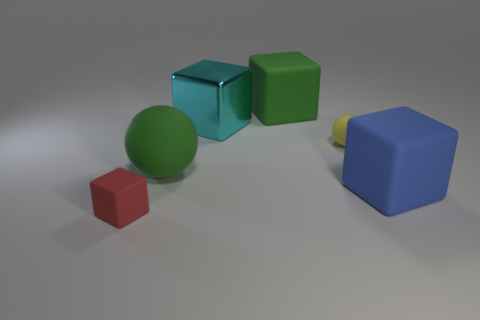Is the size of the matte cube that is behind the big cyan block the same as the green thing that is to the left of the metallic cube?
Your response must be concise. Yes. How many cylinders are tiny green things or cyan things?
Keep it short and to the point. 0. Are there any tiny matte cylinders?
Offer a terse response. No. What number of objects are either large green things that are to the left of the yellow matte ball or small red matte cubes?
Keep it short and to the point. 3. There is a rubber sphere to the left of the big rubber block behind the big metal cube; how many big matte objects are in front of it?
Keep it short and to the point. 1. Are there any other things that have the same size as the blue object?
Your response must be concise. Yes. The large green thing that is in front of the large matte object behind the sphere that is left of the shiny cube is what shape?
Provide a succinct answer. Sphere. What number of other things are there of the same color as the large metal block?
Provide a succinct answer. 0. There is a matte object to the right of the small thing that is right of the red object; what is its shape?
Provide a short and direct response. Cube. How many green rubber cubes are on the left side of the large green block?
Ensure brevity in your answer.  0. 